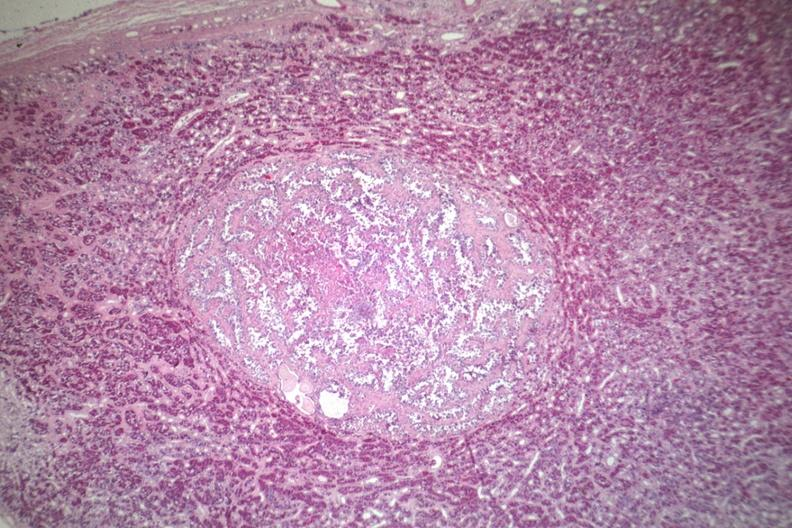s pituitary present?
Answer the question using a single word or phrase. Yes 